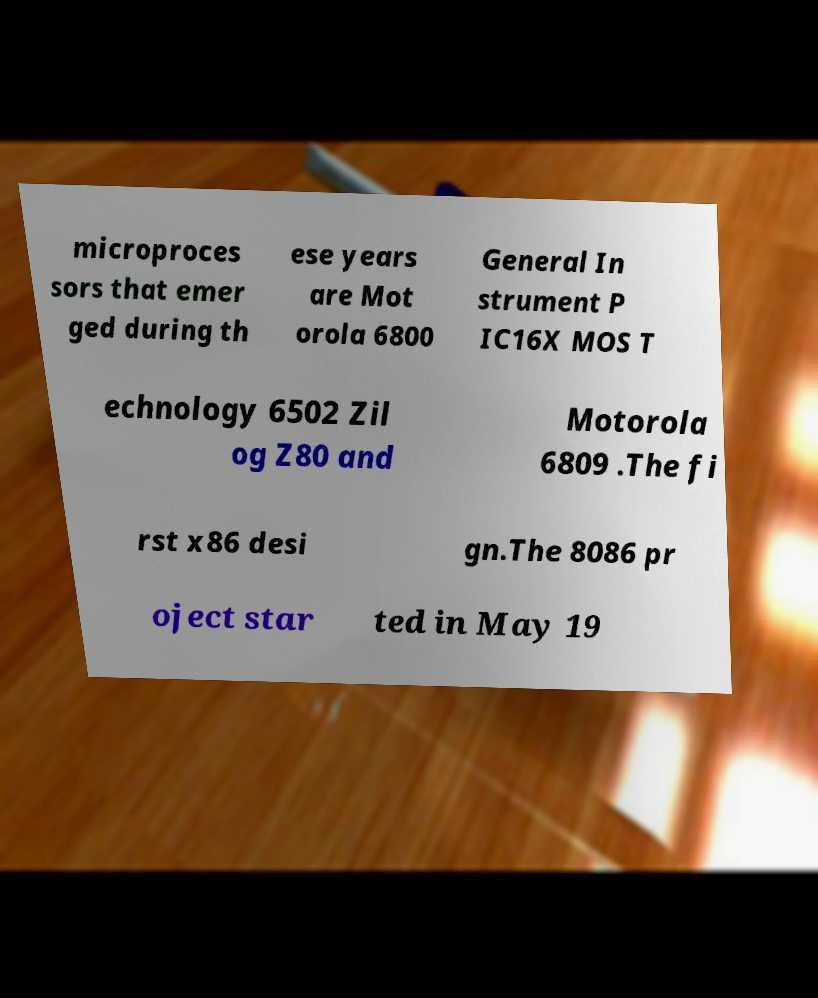Please identify and transcribe the text found in this image. microproces sors that emer ged during th ese years are Mot orola 6800 General In strument P IC16X MOS T echnology 6502 Zil og Z80 and Motorola 6809 .The fi rst x86 desi gn.The 8086 pr oject star ted in May 19 